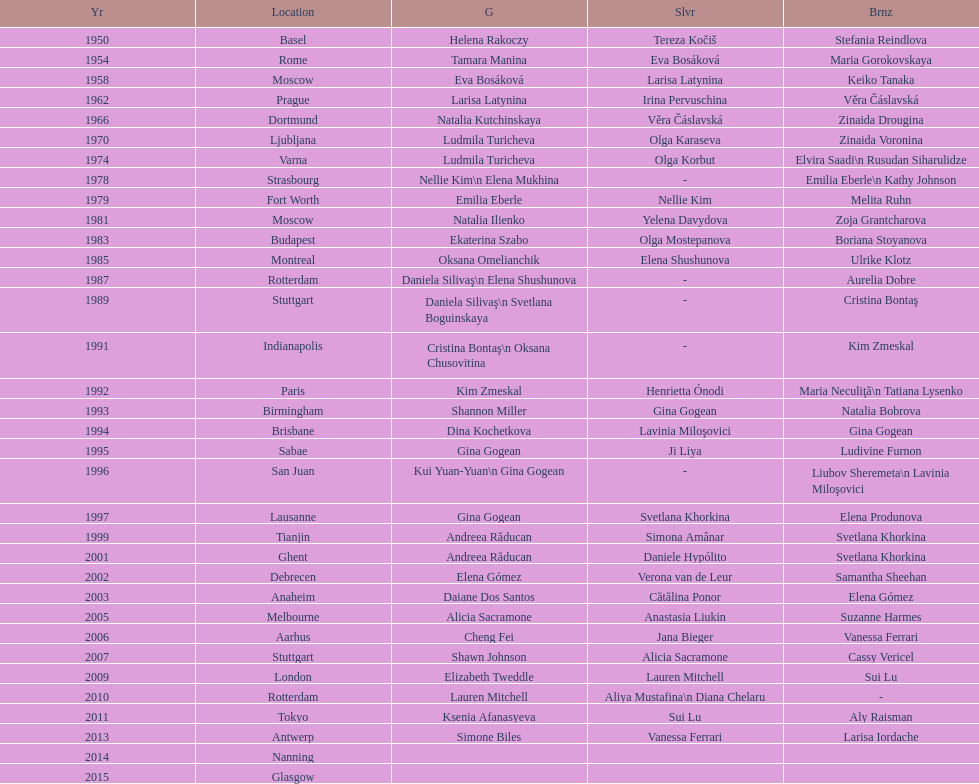How many times was the location in the united states? 3. 